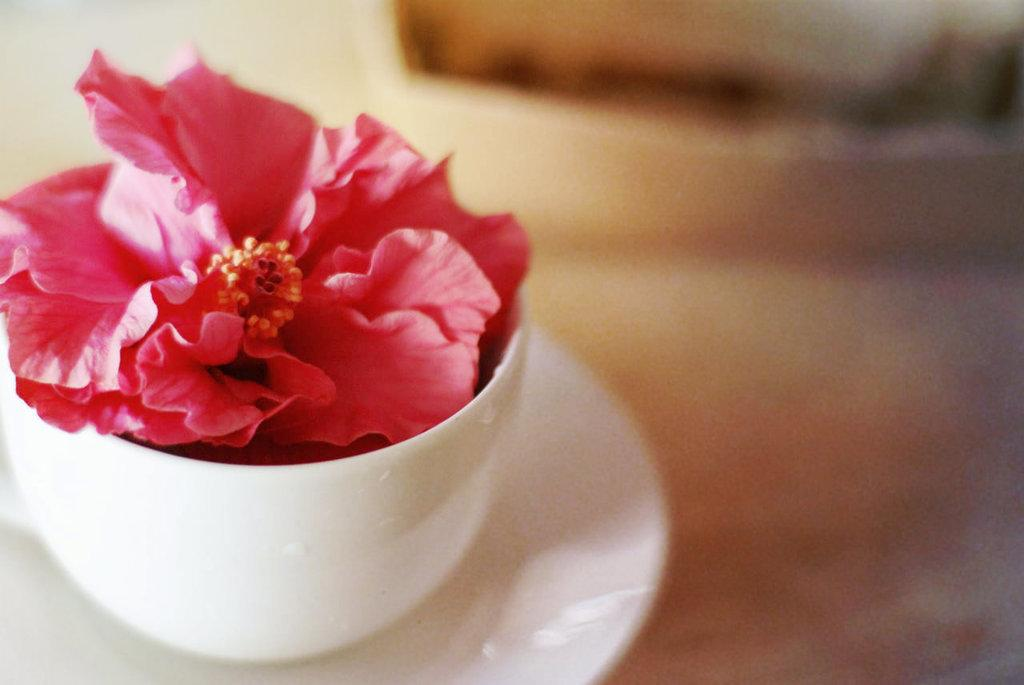What is inside the cup in the image? There is a flower in the cup. What is the cup resting on in the image? The cup is on a saucer. Can you describe the background of the image? The background of the image is blurred. What type of protest is happening in the background of the image? There is no protest present in the image; the background is blurred. 